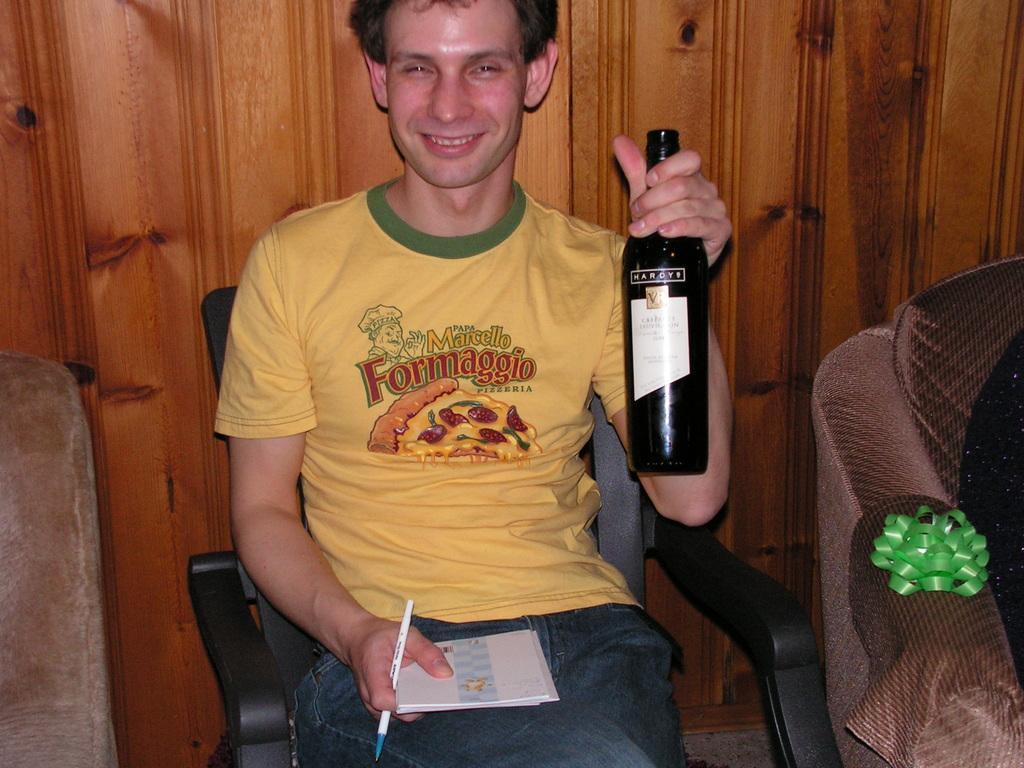Could you give a brief overview of what you see in this image? As we can see in the image there is a man sitting on chair and holding black color bottle, book and pen in his hands and on the right side there is sofa. 